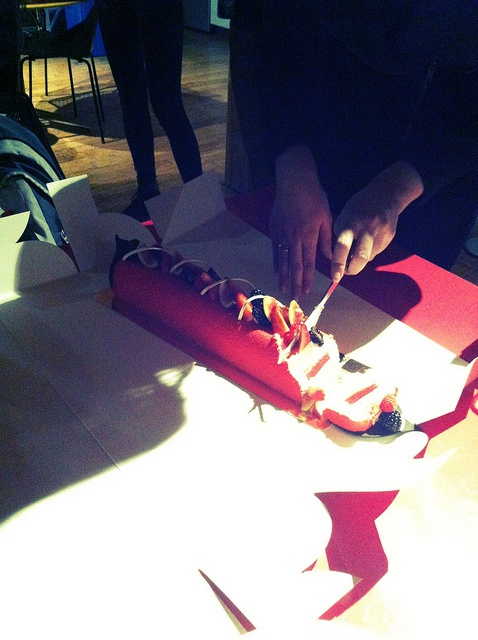Describe the objects in this image and their specific colors. I can see dining table in black, white, navy, gray, and purple tones, people in black, navy, and purple tones, cake in black, navy, ivory, purple, and brown tones, people in black, navy, and gray tones, and chair in black, tan, and khaki tones in this image. 